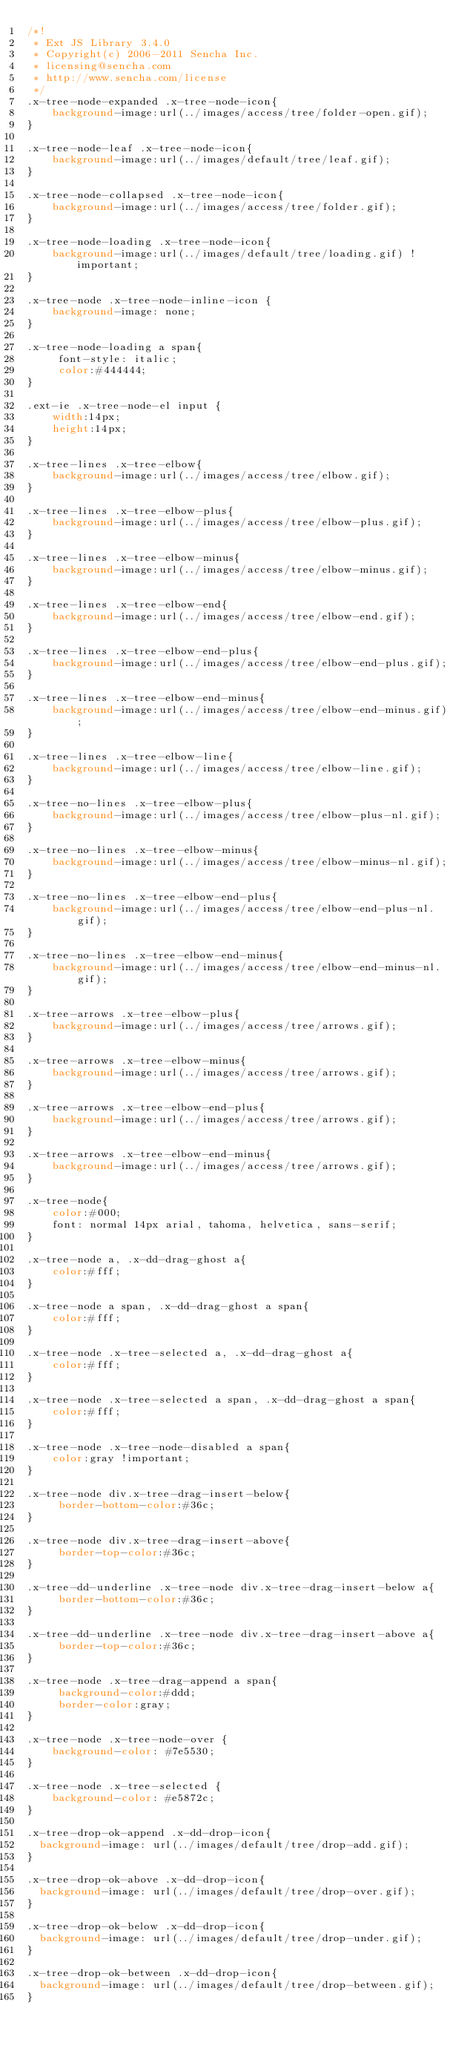<code> <loc_0><loc_0><loc_500><loc_500><_CSS_>/*!
 * Ext JS Library 3.4.0
 * Copyright(c) 2006-2011 Sencha Inc.
 * licensing@sencha.com
 * http://www.sencha.com/license
 */
.x-tree-node-expanded .x-tree-node-icon{
	background-image:url(../images/access/tree/folder-open.gif);
}

.x-tree-node-leaf .x-tree-node-icon{
	background-image:url(../images/default/tree/leaf.gif);
}

.x-tree-node-collapsed .x-tree-node-icon{
	background-image:url(../images/access/tree/folder.gif);
}

.x-tree-node-loading .x-tree-node-icon{
	background-image:url(../images/default/tree/loading.gif) !important;
}

.x-tree-node .x-tree-node-inline-icon {
    background-image: none;
}

.x-tree-node-loading a span{
	 font-style: italic;
	 color:#444444;
}

.ext-ie .x-tree-node-el input {
    width:14px;
    height:14px;
}

.x-tree-lines .x-tree-elbow{
	background-image:url(../images/access/tree/elbow.gif);
}

.x-tree-lines .x-tree-elbow-plus{
	background-image:url(../images/access/tree/elbow-plus.gif);
}

.x-tree-lines .x-tree-elbow-minus{
	background-image:url(../images/access/tree/elbow-minus.gif);
}

.x-tree-lines .x-tree-elbow-end{
	background-image:url(../images/access/tree/elbow-end.gif);
}

.x-tree-lines .x-tree-elbow-end-plus{
	background-image:url(../images/access/tree/elbow-end-plus.gif);
}

.x-tree-lines .x-tree-elbow-end-minus{
	background-image:url(../images/access/tree/elbow-end-minus.gif);
}

.x-tree-lines .x-tree-elbow-line{
	background-image:url(../images/access/tree/elbow-line.gif);
}

.x-tree-no-lines .x-tree-elbow-plus{
	background-image:url(../images/access/tree/elbow-plus-nl.gif);
}

.x-tree-no-lines .x-tree-elbow-minus{
	background-image:url(../images/access/tree/elbow-minus-nl.gif);
}

.x-tree-no-lines .x-tree-elbow-end-plus{
	background-image:url(../images/access/tree/elbow-end-plus-nl.gif);
}

.x-tree-no-lines .x-tree-elbow-end-minus{
	background-image:url(../images/access/tree/elbow-end-minus-nl.gif);
}

.x-tree-arrows .x-tree-elbow-plus{
    background-image:url(../images/access/tree/arrows.gif);
}

.x-tree-arrows .x-tree-elbow-minus{
    background-image:url(../images/access/tree/arrows.gif);
}

.x-tree-arrows .x-tree-elbow-end-plus{
    background-image:url(../images/access/tree/arrows.gif);
}

.x-tree-arrows .x-tree-elbow-end-minus{
    background-image:url(../images/access/tree/arrows.gif);
}

.x-tree-node{
	color:#000;
	font: normal 14px arial, tahoma, helvetica, sans-serif;
}

.x-tree-node a, .x-dd-drag-ghost a{
	color:#fff;
}

.x-tree-node a span, .x-dd-drag-ghost a span{
	color:#fff;
}

.x-tree-node .x-tree-selected a, .x-dd-drag-ghost a{
	color:#fff;
}

.x-tree-node .x-tree-selected a span, .x-dd-drag-ghost a span{
	color:#fff;
}

.x-tree-node .x-tree-node-disabled a span{
	color:gray !important;
}

.x-tree-node div.x-tree-drag-insert-below{
 	 border-bottom-color:#36c;
}

.x-tree-node div.x-tree-drag-insert-above{
	 border-top-color:#36c;
}

.x-tree-dd-underline .x-tree-node div.x-tree-drag-insert-below a{
 	 border-bottom-color:#36c;
}

.x-tree-dd-underline .x-tree-node div.x-tree-drag-insert-above a{
	 border-top-color:#36c;
}

.x-tree-node .x-tree-drag-append a span{
	 background-color:#ddd;
	 border-color:gray;
}

.x-tree-node .x-tree-node-over {
	background-color: #7e5530;
}

.x-tree-node .x-tree-selected {
	background-color: #e5872c;
}

.x-tree-drop-ok-append .x-dd-drop-icon{
  background-image: url(../images/default/tree/drop-add.gif);
}

.x-tree-drop-ok-above .x-dd-drop-icon{
  background-image: url(../images/default/tree/drop-over.gif);
}

.x-tree-drop-ok-below .x-dd-drop-icon{
  background-image: url(../images/default/tree/drop-under.gif);
}

.x-tree-drop-ok-between .x-dd-drop-icon{
  background-image: url(../images/default/tree/drop-between.gif);
}
</code> 